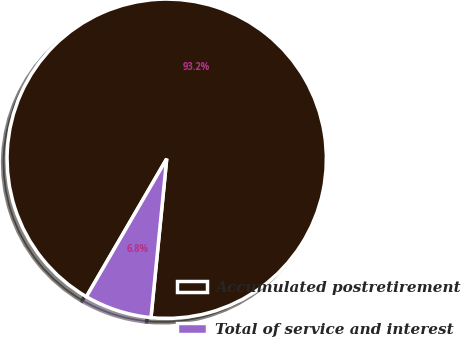Convert chart to OTSL. <chart><loc_0><loc_0><loc_500><loc_500><pie_chart><fcel>Accumulated postretirement<fcel>Total of service and interest<nl><fcel>93.18%<fcel>6.82%<nl></chart> 